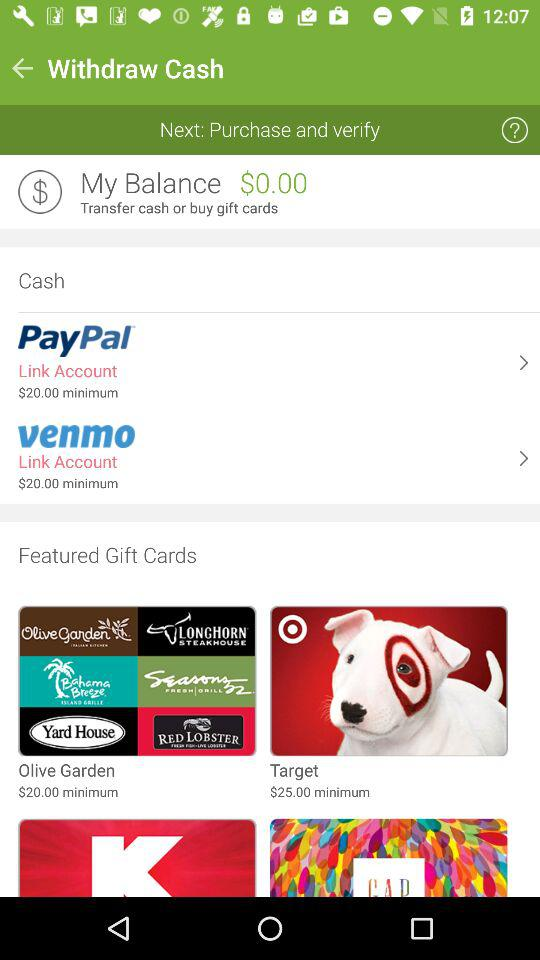What is the name of the featured gift card, whose minimum price is $25? The name of the featured gift card, whose minimum price is $25, is Target. 